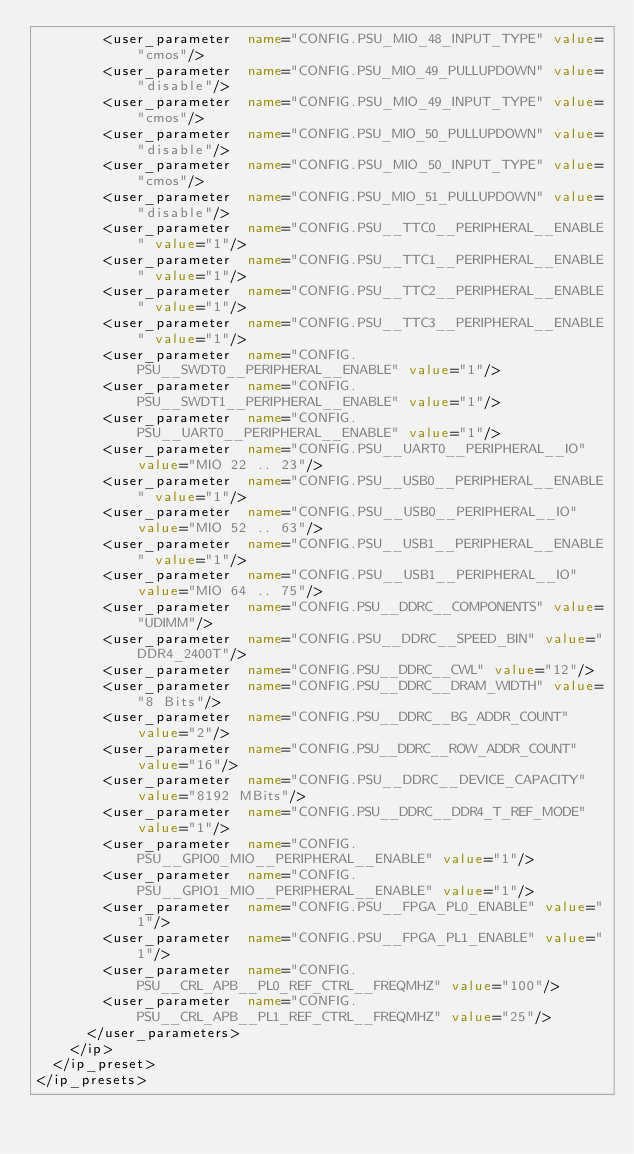Convert code to text. <code><loc_0><loc_0><loc_500><loc_500><_XML_>        <user_parameter  name="CONFIG.PSU_MIO_48_INPUT_TYPE" value="cmos"/>
        <user_parameter  name="CONFIG.PSU_MIO_49_PULLUPDOWN" value="disable"/>
        <user_parameter  name="CONFIG.PSU_MIO_49_INPUT_TYPE" value="cmos"/>
        <user_parameter  name="CONFIG.PSU_MIO_50_PULLUPDOWN" value="disable"/>
        <user_parameter  name="CONFIG.PSU_MIO_50_INPUT_TYPE" value="cmos"/>
        <user_parameter  name="CONFIG.PSU_MIO_51_PULLUPDOWN" value="disable"/>
        <user_parameter  name="CONFIG.PSU__TTC0__PERIPHERAL__ENABLE" value="1"/>
        <user_parameter  name="CONFIG.PSU__TTC1__PERIPHERAL__ENABLE" value="1"/>
        <user_parameter  name="CONFIG.PSU__TTC2__PERIPHERAL__ENABLE" value="1"/>
        <user_parameter  name="CONFIG.PSU__TTC3__PERIPHERAL__ENABLE" value="1"/>
        <user_parameter  name="CONFIG.PSU__SWDT0__PERIPHERAL__ENABLE" value="1"/>
        <user_parameter  name="CONFIG.PSU__SWDT1__PERIPHERAL__ENABLE" value="1"/>
        <user_parameter  name="CONFIG.PSU__UART0__PERIPHERAL__ENABLE" value="1"/>
        <user_parameter  name="CONFIG.PSU__UART0__PERIPHERAL__IO" value="MIO 22 .. 23"/>
        <user_parameter  name="CONFIG.PSU__USB0__PERIPHERAL__ENABLE" value="1"/>
        <user_parameter  name="CONFIG.PSU__USB0__PERIPHERAL__IO" value="MIO 52 .. 63"/>
        <user_parameter  name="CONFIG.PSU__USB1__PERIPHERAL__ENABLE" value="1"/>
        <user_parameter  name="CONFIG.PSU__USB1__PERIPHERAL__IO" value="MIO 64 .. 75"/>
        <user_parameter  name="CONFIG.PSU__DDRC__COMPONENTS" value="UDIMM"/>
        <user_parameter  name="CONFIG.PSU__DDRC__SPEED_BIN" value="DDR4_2400T"/>
        <user_parameter  name="CONFIG.PSU__DDRC__CWL" value="12"/>
        <user_parameter  name="CONFIG.PSU__DDRC__DRAM_WIDTH" value="8 Bits"/>
        <user_parameter  name="CONFIG.PSU__DDRC__BG_ADDR_COUNT" value="2"/>
        <user_parameter  name="CONFIG.PSU__DDRC__ROW_ADDR_COUNT" value="16"/>
        <user_parameter  name="CONFIG.PSU__DDRC__DEVICE_CAPACITY" value="8192 MBits"/>
        <user_parameter  name="CONFIG.PSU__DDRC__DDR4_T_REF_MODE" value="1"/>
        <user_parameter  name="CONFIG.PSU__GPIO0_MIO__PERIPHERAL__ENABLE" value="1"/>
        <user_parameter  name="CONFIG.PSU__GPIO1_MIO__PERIPHERAL__ENABLE" value="1"/>
        <user_parameter  name="CONFIG.PSU__FPGA_PL0_ENABLE" value="1"/>
        <user_parameter  name="CONFIG.PSU__FPGA_PL1_ENABLE" value="1"/>
        <user_parameter  name="CONFIG.PSU__CRL_APB__PL0_REF_CTRL__FREQMHZ" value="100"/>
        <user_parameter  name="CONFIG.PSU__CRL_APB__PL1_REF_CTRL__FREQMHZ" value="25"/>
      </user_parameters>
    </ip>
  </ip_preset>
</ip_presets>
</code> 